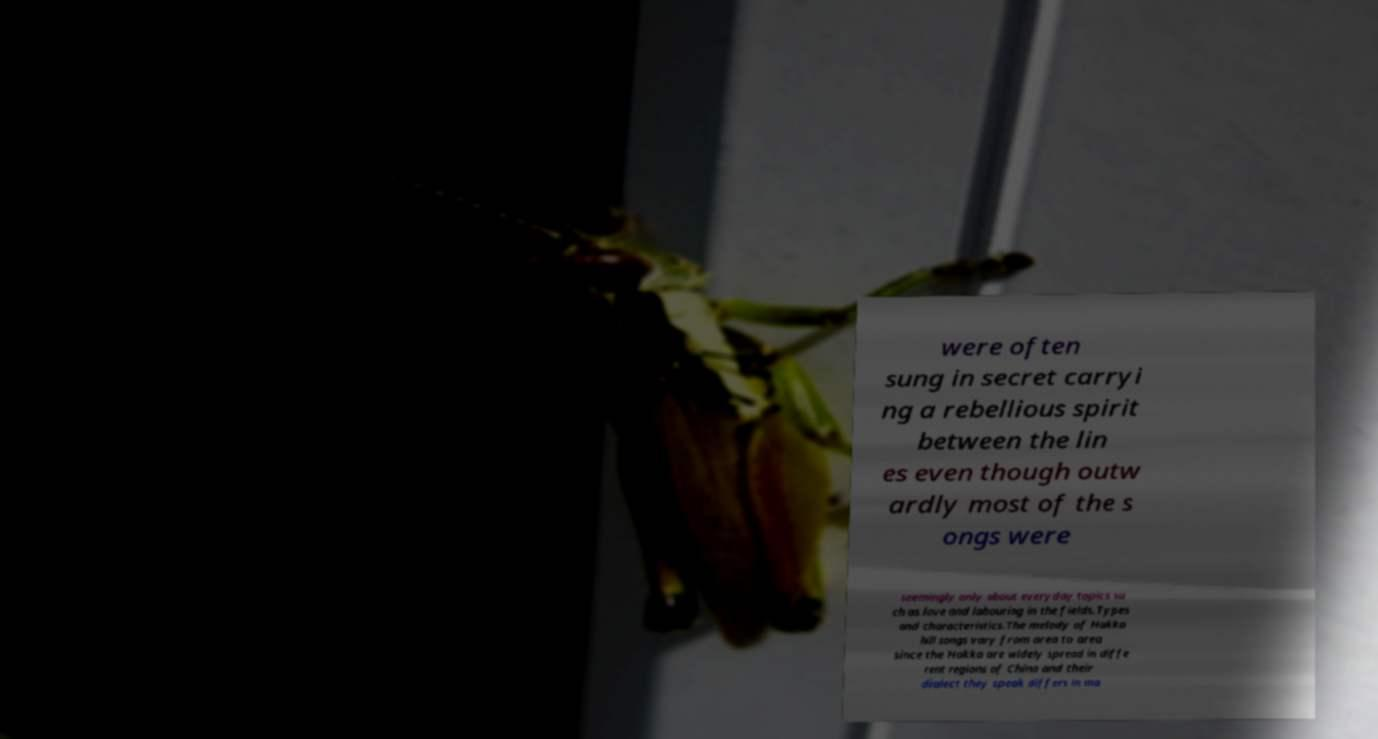Can you accurately transcribe the text from the provided image for me? were often sung in secret carryi ng a rebellious spirit between the lin es even though outw ardly most of the s ongs were seemingly only about everyday topics su ch as love and labouring in the fields.Types and characteristics.The melody of Hakka hill songs vary from area to area since the Hakka are widely spread in diffe rent regions of China and their dialect they speak differs in ma 